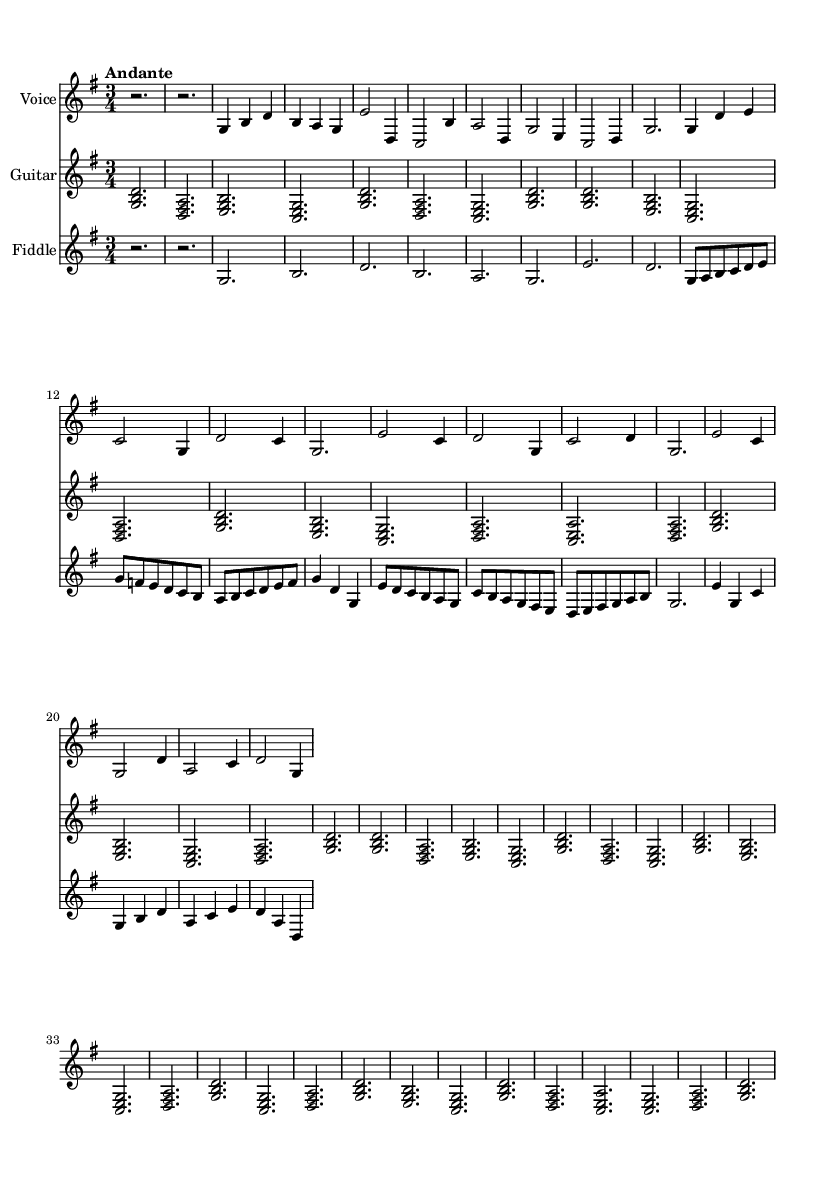What is the key signature of this music? The key signature is indicated at the beginning of the staff and shows one sharp, which suggests the music is in G major.
Answer: G major What is the time signature of this music? The time signature is located at the beginning of the music, showing three beats per measure, indicated by the fraction 3/4.
Answer: 3/4 What is the tempo marking of this music? The tempo marking is indicated just above the staff and reads "Andante," which signifies a moderately slow tempo.
Answer: Andante How many instruments are included in this score? The score contains three staves, each labeled for a specific instrument: Voice, Guitar, and Fiddle, which totals three instruments.
Answer: Three What is the predominant theme of the lyrics? The lyrics express the partnership and dedication between the country doctor and the midwife in providing healthcare in rural settings, focusing on their journey and teamwork.
Answer: Rural healthcare partnership Which musical section has the most notes in the treble clef? If we analyze the sections of the song, the Chorus has the most notes as indicated by the more extensive melodic patterns and flow compared to the verse and bridge.
Answer: Chorus What musical technique is exemplified in the Bridge section? The Bridge employs varying note lengths and rhythmic patterns to create contrast and build emotion, a common technique in Romantic music, emphasizing the changing dynamics of the narrative.
Answer: Contrast in dynamics 